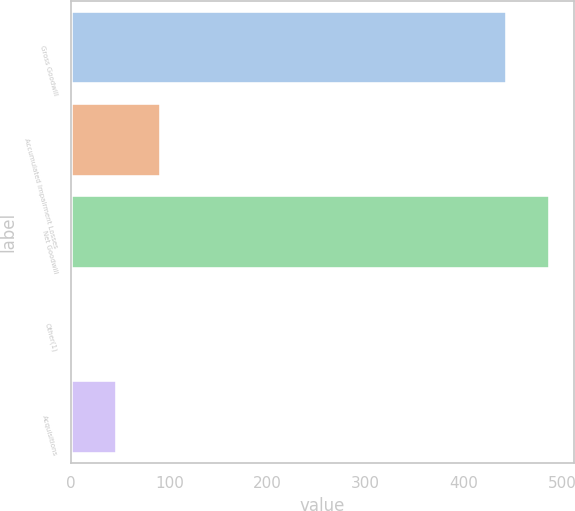Convert chart. <chart><loc_0><loc_0><loc_500><loc_500><bar_chart><fcel>Gross Goodwill<fcel>Accumulated Impairment Losses<fcel>Net Goodwill<fcel>Other(1)<fcel>Acquisitions<nl><fcel>444<fcel>91.07<fcel>488.12<fcel>2.83<fcel>46.95<nl></chart> 